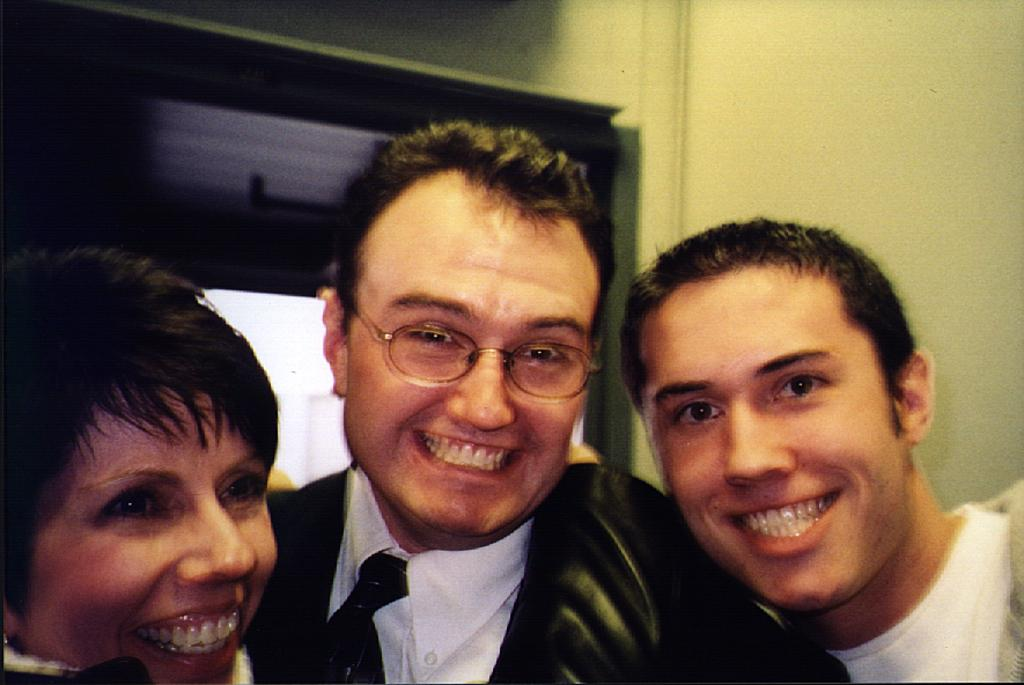What is the main subject in the center of the image? There is a group of people in the center of the image. Where is the door located in the image? The door is on the left side of the image. Can you describe the location of the door in relation to the group of people? The door is in the background area of the image, behind the group of people. What type of bead is hanging from the door in the image? There is no bead hanging from the door in the image. How does the wilderness affect the group of people in the image? There is no wilderness present in the image; it features a group of people and a door. 